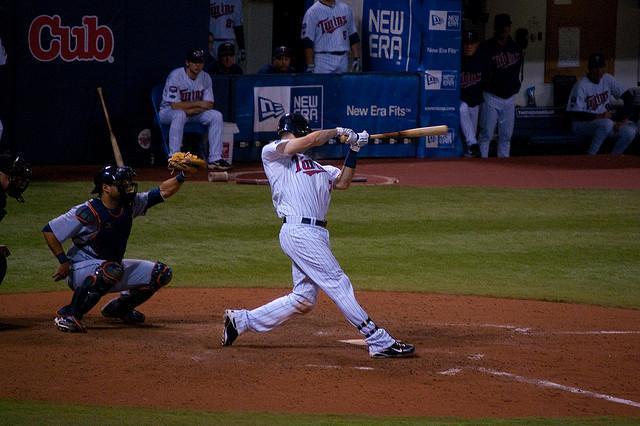What cap/apparel company is a sponsor for the stadium?
From the following set of four choices, select the accurate answer to respond to the question.
Options: New era, adidas, nike, cub. New era. 